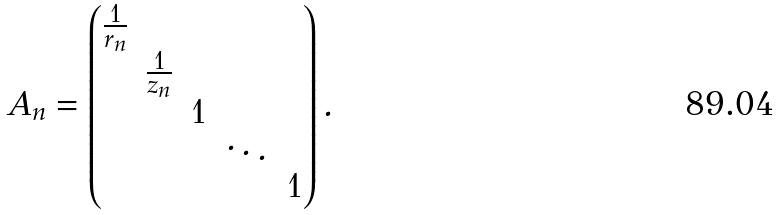Convert formula to latex. <formula><loc_0><loc_0><loc_500><loc_500>A _ { n } = \begin{pmatrix} \frac { 1 } { r _ { n } } & & & & \\ & \frac { 1 } { z _ { n } } & & & \\ & & 1 & & \\ & & & \ddots & \\ & & & & 1 \end{pmatrix} .</formula> 